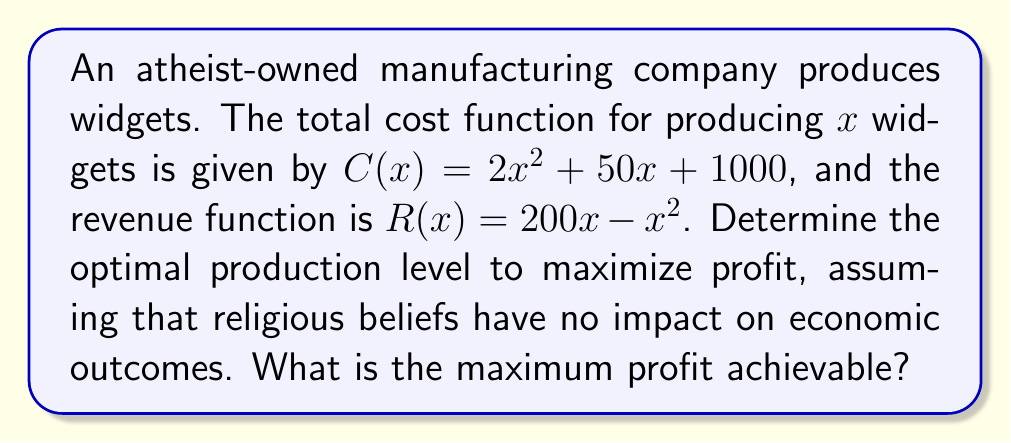Show me your answer to this math problem. To solve this problem, we'll follow these steps:

1) First, let's define the profit function $P(x)$:
   $P(x) = R(x) - C(x)$
   $P(x) = (200x - x^2) - (2x^2 + 50x + 1000)$
   $P(x) = -3x^2 + 150x - 1000$

2) To find the maximum profit, we need to find where the derivative of $P(x)$ equals zero:
   $\frac{dP}{dx} = -6x + 150$
   Set this equal to zero:
   $-6x + 150 = 0$
   $-6x = -150$
   $x = 25$

3) To confirm this is a maximum (not a minimum), we can check the second derivative:
   $\frac{d^2P}{dx^2} = -6$
   Since this is negative, we confirm that $x = 25$ gives a maximum.

4) Now, let's calculate the maximum profit by plugging $x = 25$ into our profit function:
   $P(25) = -3(25)^2 + 150(25) - 1000$
   $= -1875 + 3750 - 1000$
   $= 875$

Therefore, the optimal production level is 25 widgets, and the maximum profit is $875.

This solution is based purely on mathematical optimization, without any consideration of religious factors, aligning with the economic professor's perspective that religious beliefs do not influence economic outcomes.
Answer: Optimal production level: 25 widgets
Maximum profit: $875 